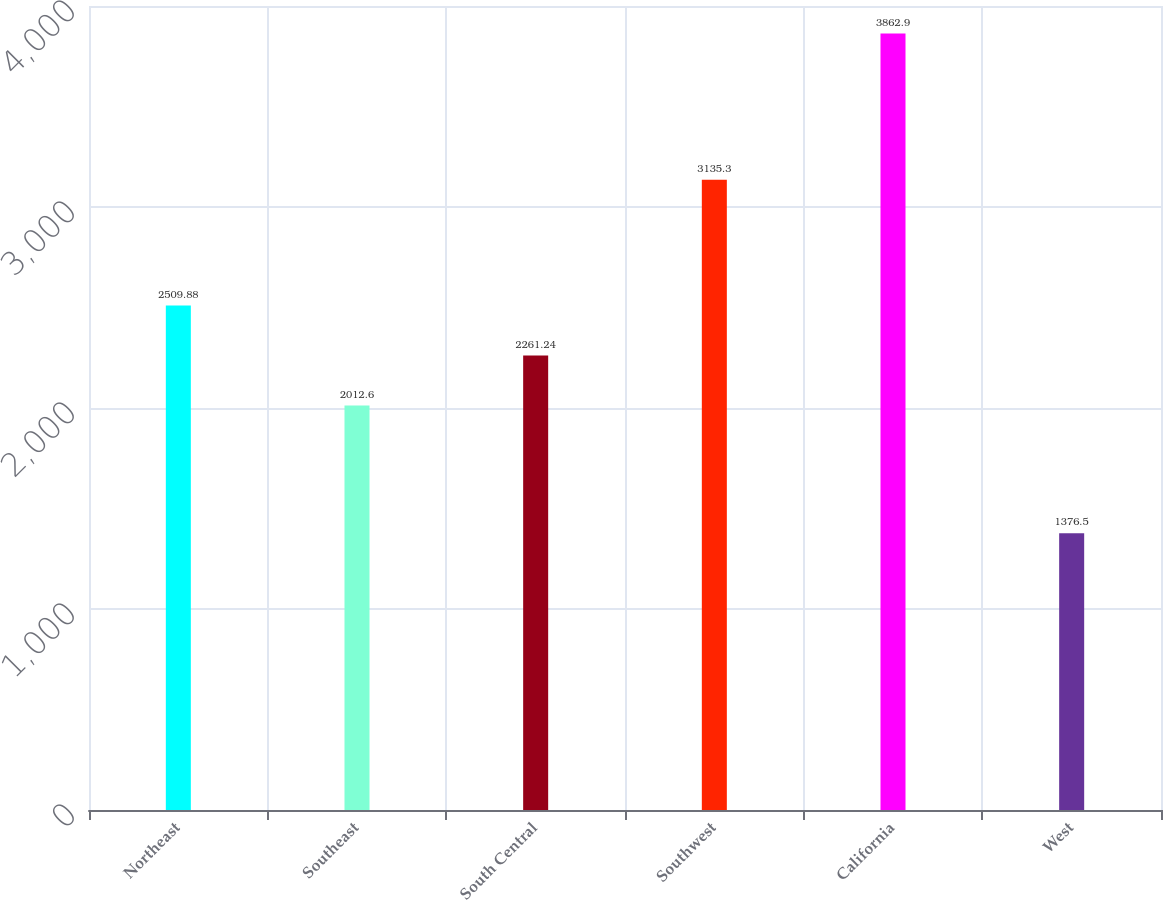Convert chart. <chart><loc_0><loc_0><loc_500><loc_500><bar_chart><fcel>Northeast<fcel>Southeast<fcel>South Central<fcel>Southwest<fcel>California<fcel>West<nl><fcel>2509.88<fcel>2012.6<fcel>2261.24<fcel>3135.3<fcel>3862.9<fcel>1376.5<nl></chart> 